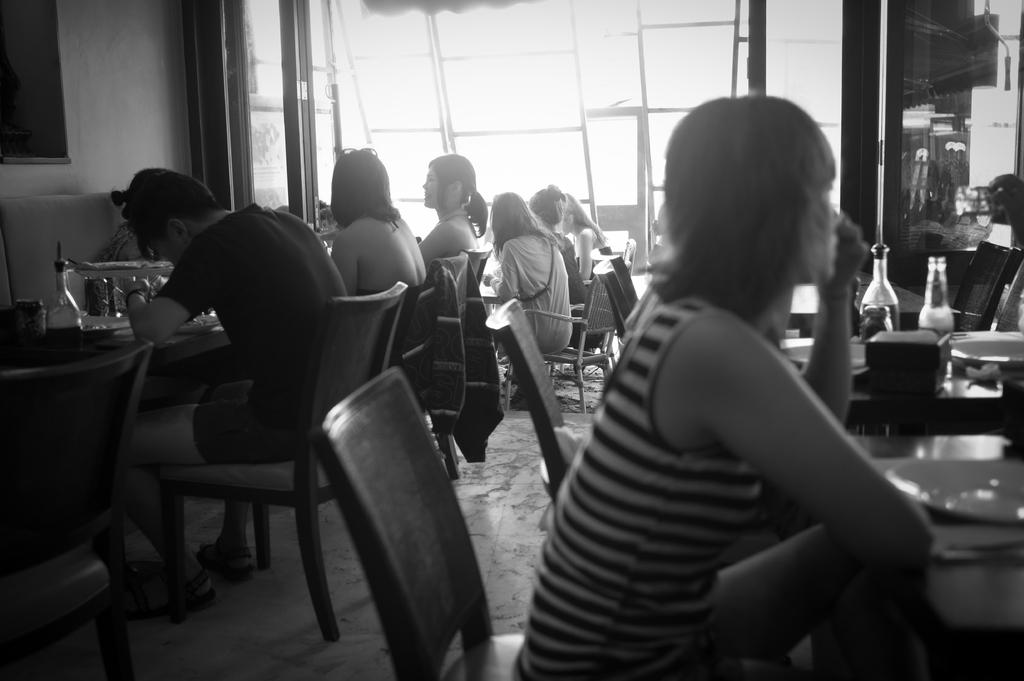What are the persons in the image doing? The persons in the image are sitting on chairs. What objects can be seen on the tables? There are bottles and plates on the tables. What can be seen in the background of the image? There is a wall visible in the background. What type of noise is the monkey making in the image? There is no monkey present in the image, so it is not possible to determine what noise it might be making. 